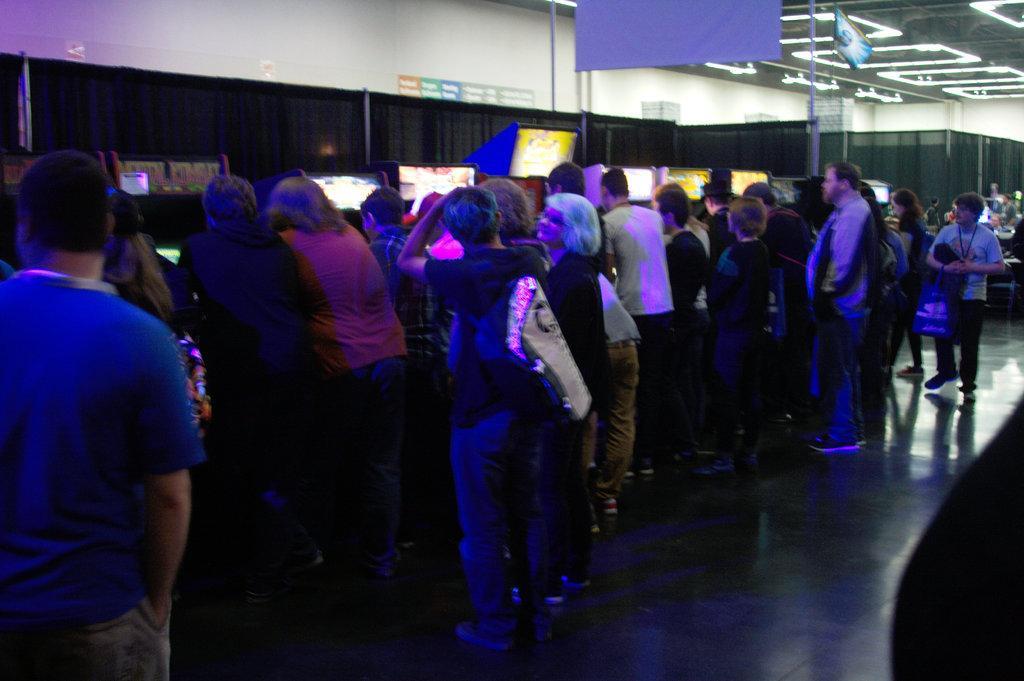In one or two sentences, can you explain what this image depicts? In this picture I can see there are a group of people standing here and there are display screens here on the wall and there are lights attached to the ceiling. 